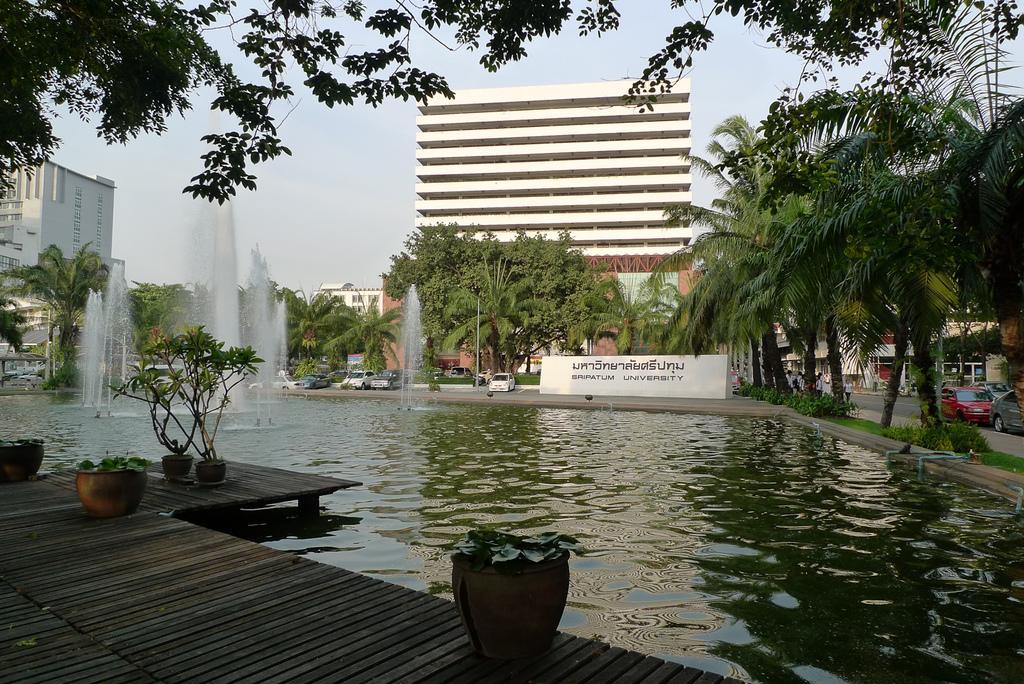In one or two sentences, can you explain what this image depicts? In the background we can see the sky, buildings, trees, vehicles and the people. In this picture we can see the water, wooden platform, pots, plants, water fountains. We can see there is something written on the wall. 